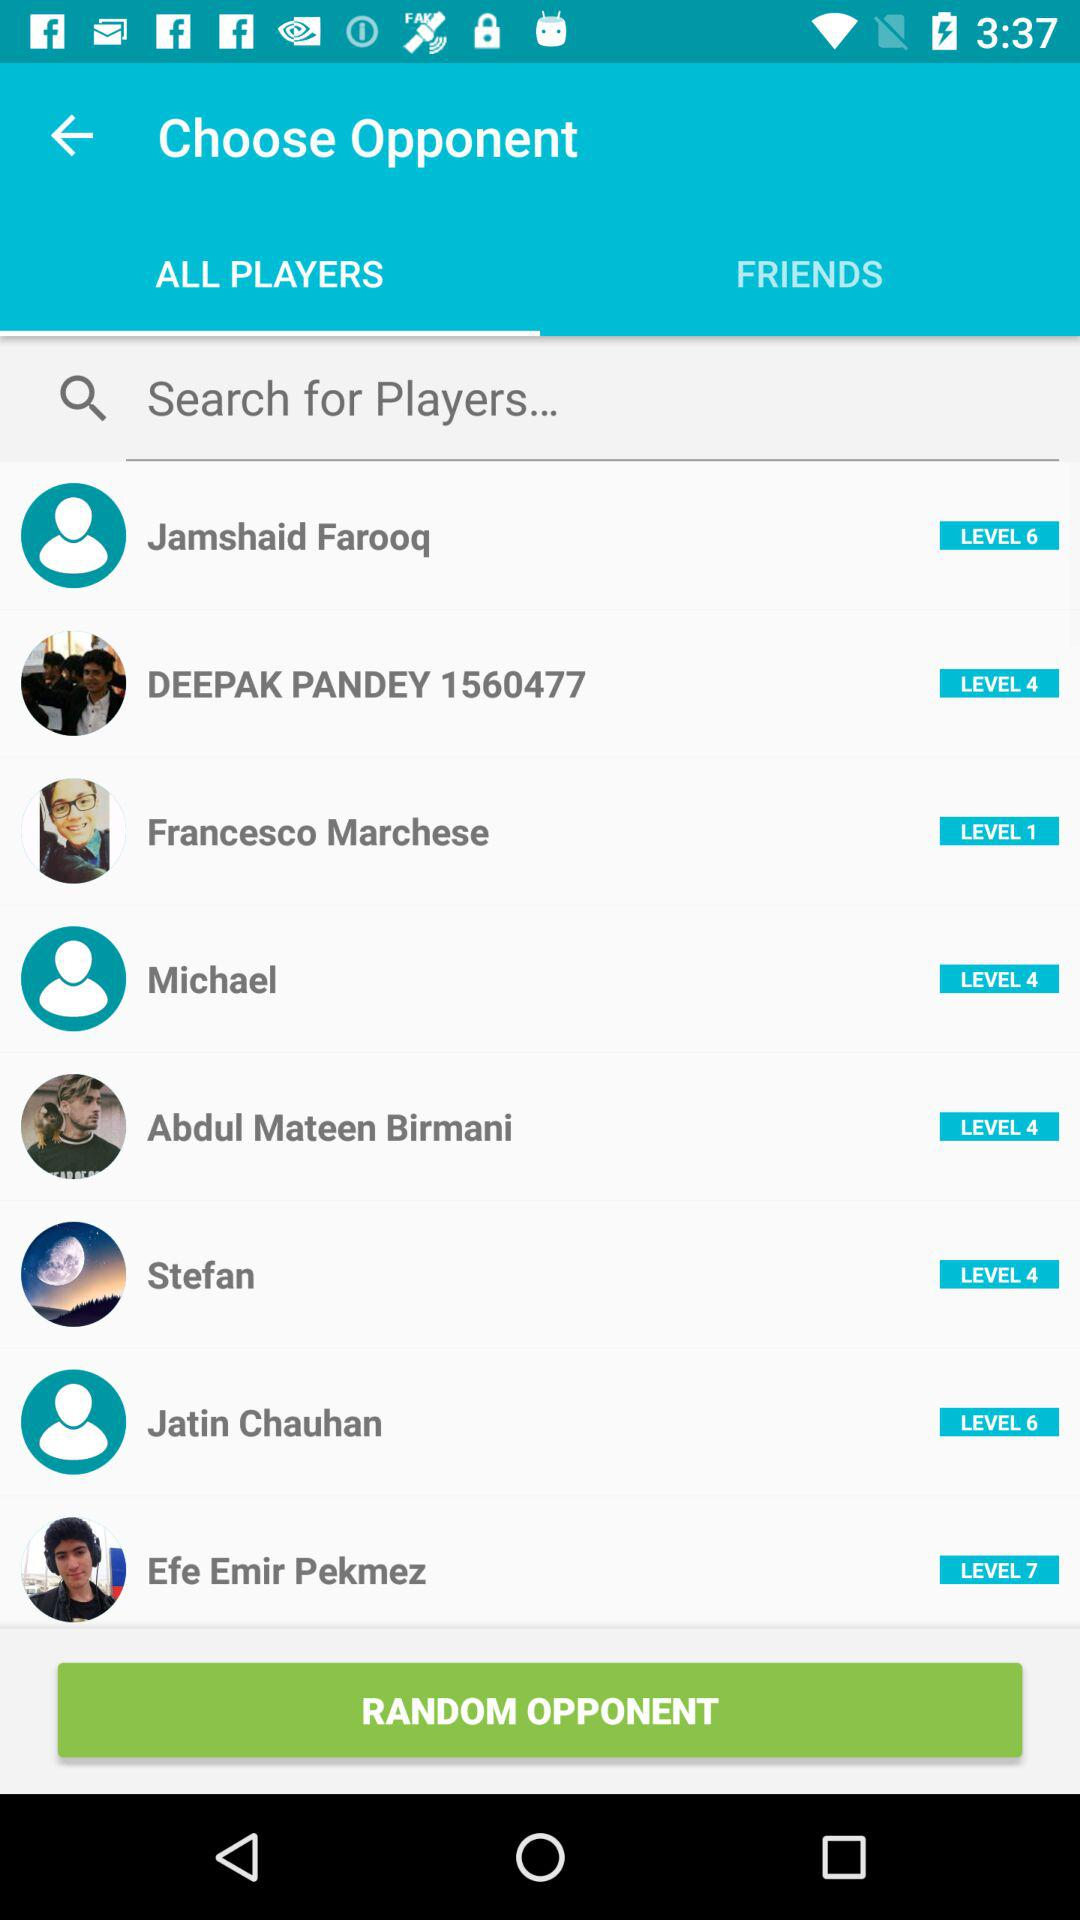Who is at level 7? At Level 7, Efe Emir Pekmez is present. 